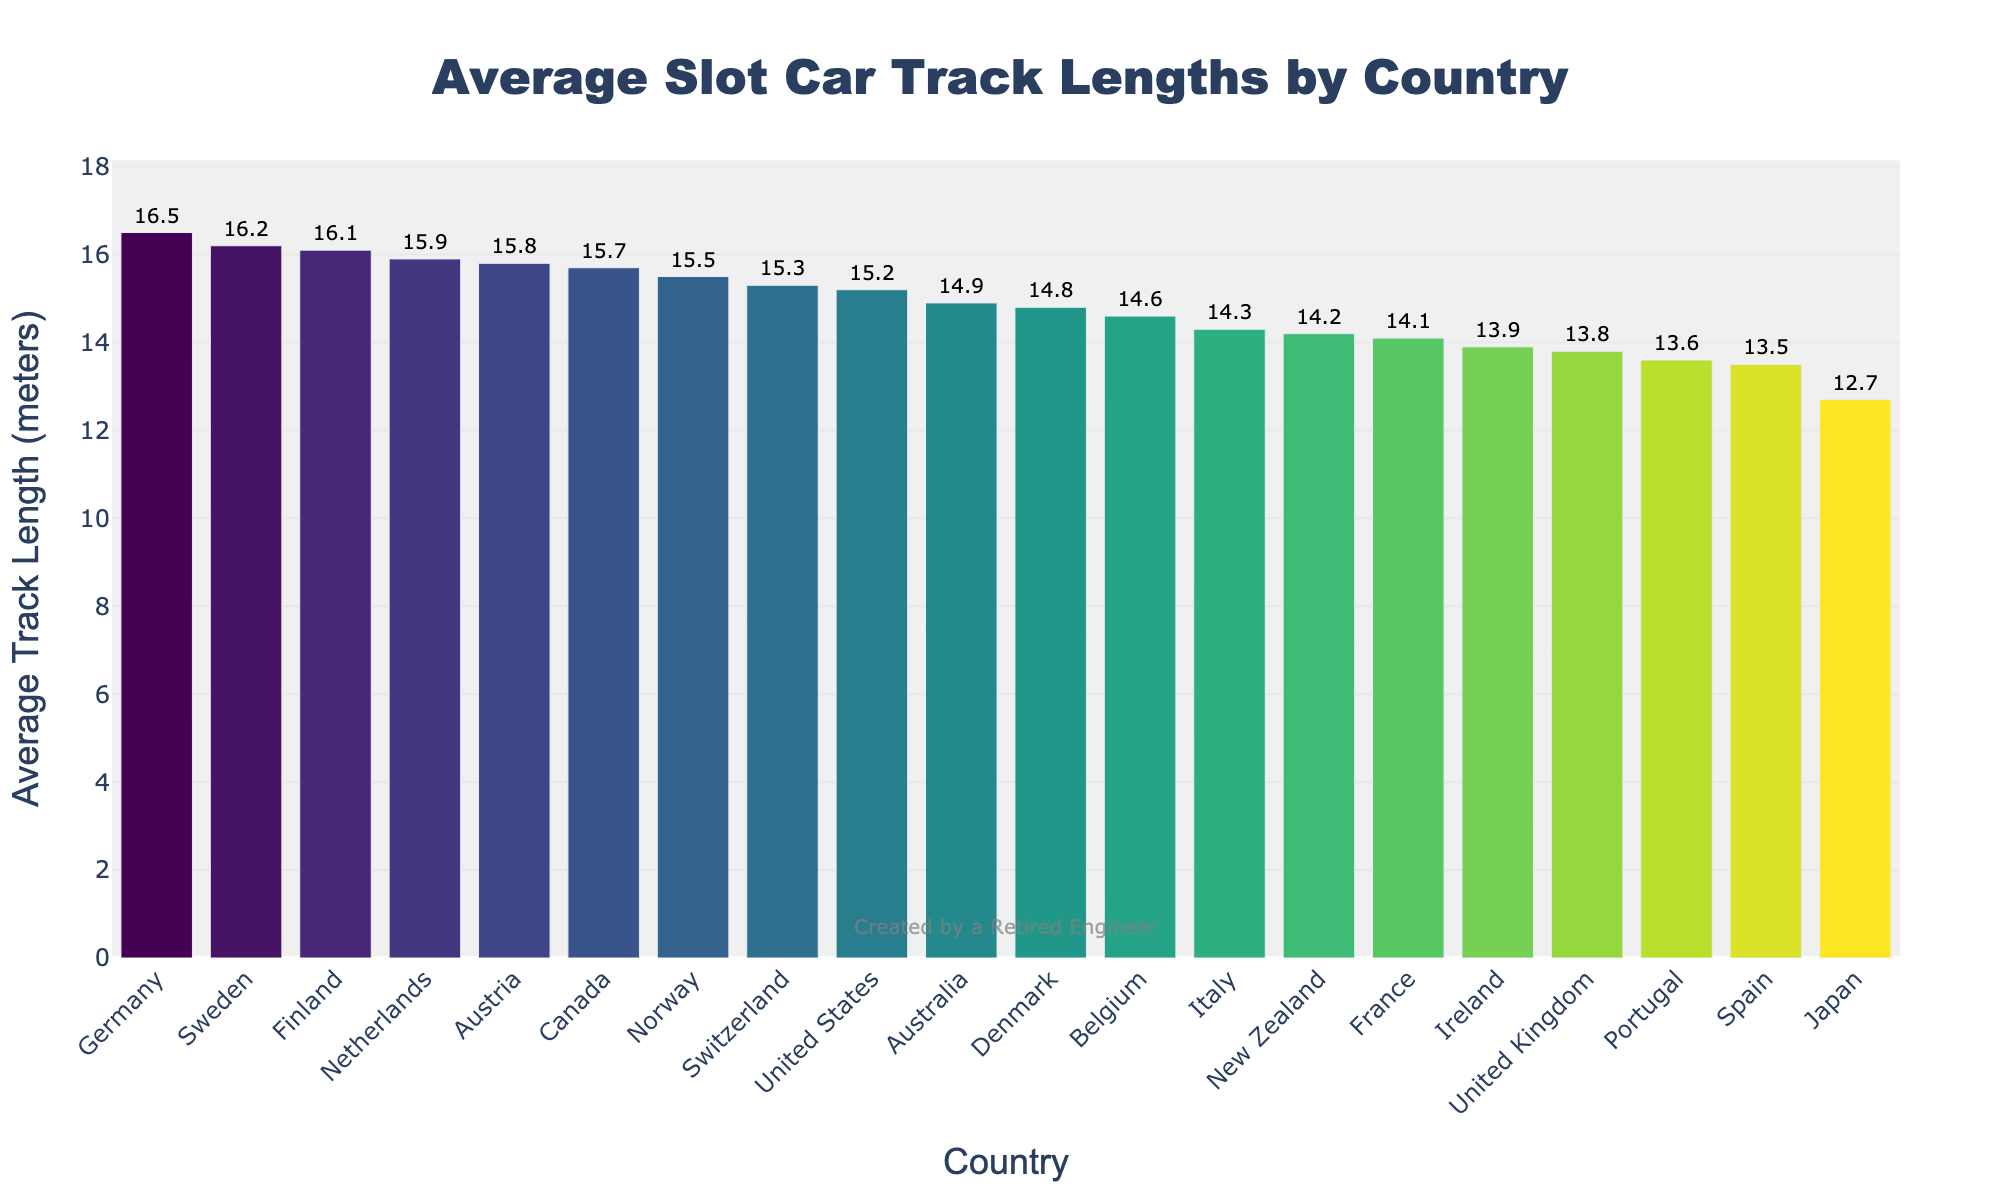Which country has the longest average slot car track length? Look at the highest bar in the chart, which represents the country with the longest track length. The top bar is marked as Germany with a track length of 16.5 meters.
Answer: Germany Which country has the shortest average slot car track length? Look at the shortest bar in the chart, which corresponds to the country with the shortest track length. The lowest bar is marked as Japan with a length of 12.7 meters.
Answer: Japan Which country has a longer average track length, United States or France? Compare the heights of the bars labeled United States and France. The bar for the United States is taller than the bar for France, indicating a longer average track length.
Answer: United States What is the difference in average track length between the Netherlands and Australia? Identify the bar heights for the Netherlands and Australia, which are 15.9 meters and 14.9 meters, respectively. Subtract the smaller value from the larger one: 15.9 - 14.9 = 1.0 meters.
Answer: 1.0 meters If you combined the average track lengths of Germany and Sweden, what would be the total length? Locate the bars for Germany and Sweden, which have lengths of 16.5 meters and 16.2 meters, respectively. Add these values together: 16.5 + 16.2 = 32.7 meters.
Answer: 32.7 meters Which country’s average track length is closest to 15 meters? Look for the bar whose value is closest to 15 meters. It is the bar for Norway, with a length of 15.5 meters, which is the closest value.
Answer: Norway How many countries have an average track length greater than 15 meters? Count all the bars with a length greater than 15 meters. The countries are United States (15.2), Germany (16.5), Canada (15.7), Netherlands (15.9), Sweden (16.2), Switzerland (15.3), Austria (15.8), Norway (15.5), and Finland (16.1). There are 9 countries in total.
Answer: 9 Which two countries have the smallest difference in their average track length? Find pairs of bars that are close in height and calculate their differences. Ireland (13.9) and United Kingdom (13.8) have a difference of 0.1 meters, which is the smallest difference.
Answer: Ireland and United Kingdom 